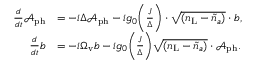<formula> <loc_0><loc_0><loc_500><loc_500>\begin{array} { r l } { \frac { d } { d t } \mathcal { A } _ { p h } } & { = - i \Delta \mathcal { A } _ { p h } - i g _ { 0 } \left ( \frac { J } { \Delta } \right ) \cdot \sqrt { ( { n } _ { L } - \tilde { n } _ { a } ) } \cdot b , } \\ { \frac { d } { d t } b } & { = - i \Omega _ { v } b - i g _ { 0 } \left ( \frac { J } { \Delta } \right ) \sqrt { ( { n } _ { L } - \tilde { n } _ { a } ) } \cdot \mathcal { A } _ { p h } . } \end{array}</formula> 